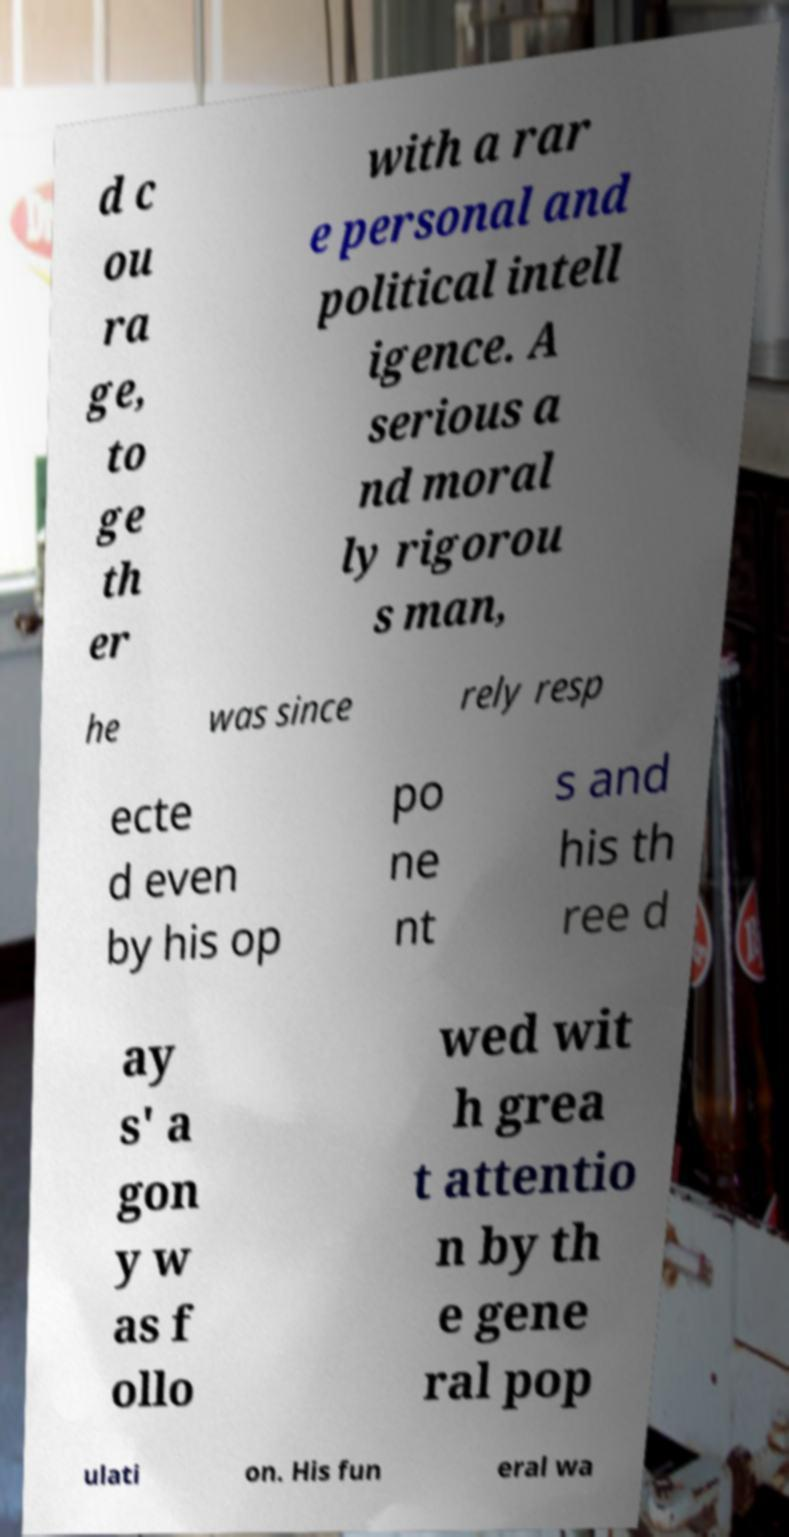Could you extract and type out the text from this image? d c ou ra ge, to ge th er with a rar e personal and political intell igence. A serious a nd moral ly rigorou s man, he was since rely resp ecte d even by his op po ne nt s and his th ree d ay s' a gon y w as f ollo wed wit h grea t attentio n by th e gene ral pop ulati on. His fun eral wa 